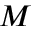Convert formula to latex. <formula><loc_0><loc_0><loc_500><loc_500>M</formula> 